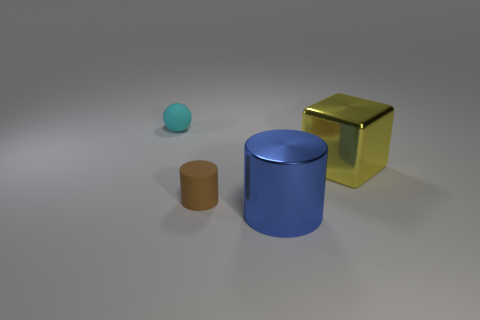There is a blue thing that is the same shape as the brown rubber object; what is its material?
Your answer should be very brief. Metal. What is the shape of the shiny thing that is behind the brown cylinder right of the cyan matte thing?
Provide a short and direct response. Cube. Is the big object that is in front of the brown thing made of the same material as the small cyan sphere?
Your response must be concise. No. Is the number of metallic cylinders that are to the right of the metal cylinder the same as the number of metallic things that are behind the brown matte thing?
Give a very brief answer. No. How many small cylinders are behind the big yellow block that is behind the small brown cylinder?
Offer a terse response. 0. There is a blue cylinder that is the same size as the block; what is it made of?
Your response must be concise. Metal. There is a large thing that is behind the large metallic thing that is in front of the thing on the right side of the blue object; what shape is it?
Keep it short and to the point. Cube. What is the shape of the cyan thing that is the same size as the brown matte thing?
Your answer should be compact. Sphere. How many tiny cyan matte things are in front of the matte thing on the left side of the small brown rubber object that is in front of the metallic cube?
Your answer should be compact. 0. Is the number of small matte objects that are in front of the tiny sphere greater than the number of big blue cylinders that are behind the big blue object?
Provide a short and direct response. Yes. 